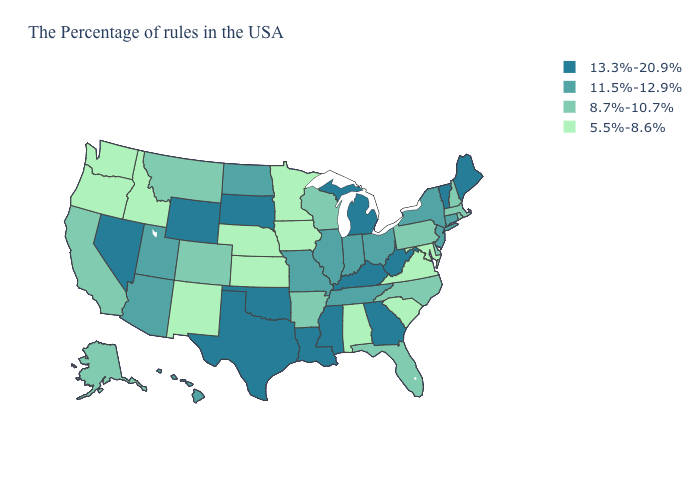What is the value of Ohio?
Give a very brief answer. 11.5%-12.9%. What is the value of South Carolina?
Be succinct. 5.5%-8.6%. Among the states that border Vermont , which have the lowest value?
Be succinct. Massachusetts, New Hampshire. Does South Dakota have the highest value in the MidWest?
Keep it brief. Yes. What is the value of Arkansas?
Write a very short answer. 8.7%-10.7%. Does the map have missing data?
Short answer required. No. What is the value of Virginia?
Quick response, please. 5.5%-8.6%. Name the states that have a value in the range 11.5%-12.9%?
Be succinct. Connecticut, New York, New Jersey, Ohio, Indiana, Tennessee, Illinois, Missouri, North Dakota, Utah, Arizona, Hawaii. Among the states that border Illinois , which have the highest value?
Keep it brief. Kentucky. Does Maine have a lower value than Nevada?
Concise answer only. No. Does Utah have the lowest value in the West?
Write a very short answer. No. Is the legend a continuous bar?
Keep it brief. No. What is the lowest value in states that border Alabama?
Keep it brief. 8.7%-10.7%. Name the states that have a value in the range 13.3%-20.9%?
Quick response, please. Maine, Vermont, West Virginia, Georgia, Michigan, Kentucky, Mississippi, Louisiana, Oklahoma, Texas, South Dakota, Wyoming, Nevada. Which states have the lowest value in the USA?
Short answer required. Maryland, Virginia, South Carolina, Alabama, Minnesota, Iowa, Kansas, Nebraska, New Mexico, Idaho, Washington, Oregon. 